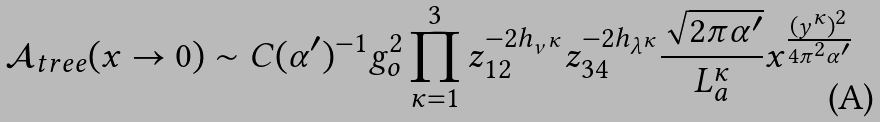Convert formula to latex. <formula><loc_0><loc_0><loc_500><loc_500>\mathcal { A } _ { t r e e } ( x \rightarrow 0 ) \sim C ( \alpha ^ { \prime } ) ^ { - 1 } g _ { o } ^ { 2 } \prod _ { \kappa = 1 } ^ { 3 } z _ { 1 2 } ^ { - 2 h _ { \nu ^ { \kappa } } } z _ { 3 4 } ^ { - 2 h _ { \lambda ^ { \kappa } } } \frac { \sqrt { 2 \pi \alpha ^ { \prime } } } { L _ { a } ^ { \kappa } } x ^ { \frac { ( y ^ { \kappa } ) ^ { 2 } } { 4 \pi ^ { 2 } \alpha ^ { \prime } } }</formula> 